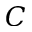Convert formula to latex. <formula><loc_0><loc_0><loc_500><loc_500>C</formula> 